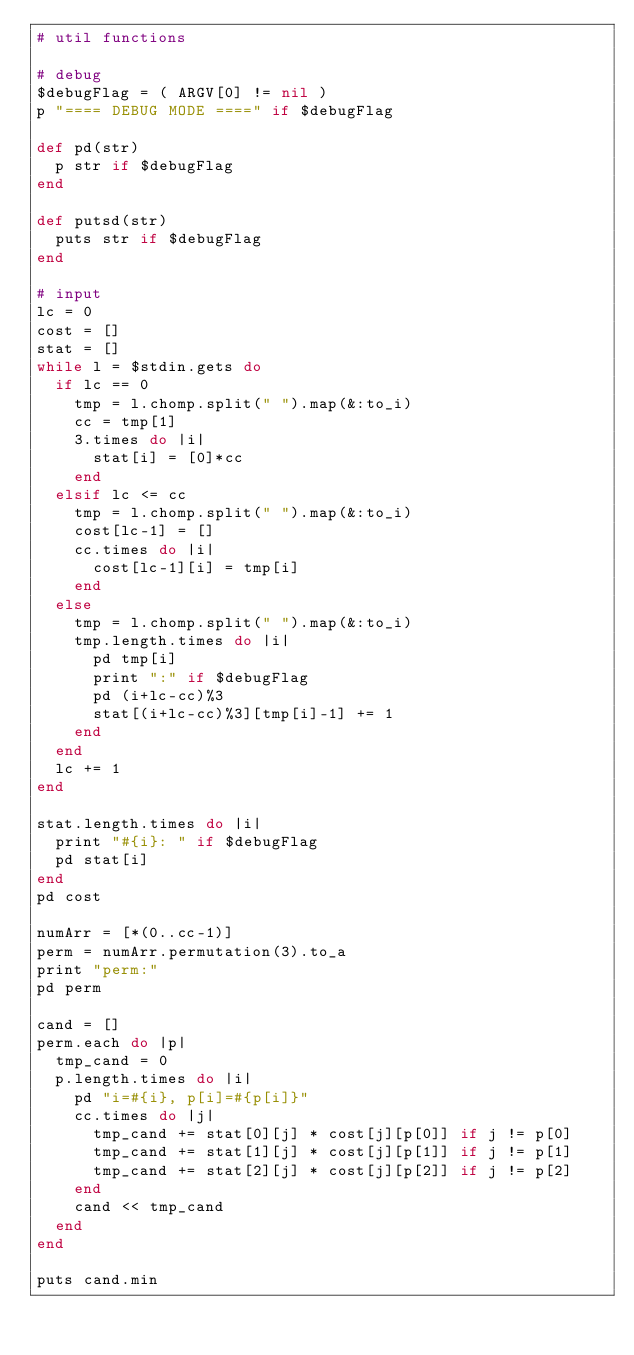<code> <loc_0><loc_0><loc_500><loc_500><_Ruby_># util functions

# debug
$debugFlag = ( ARGV[0] != nil )
p "==== DEBUG MODE ====" if $debugFlag

def pd(str)
  p str if $debugFlag
end

def putsd(str)
  puts str if $debugFlag
end

# input
lc = 0
cost = []
stat = []
while l = $stdin.gets do
  if lc == 0
    tmp = l.chomp.split(" ").map(&:to_i)
    cc = tmp[1]
    3.times do |i|
      stat[i] = [0]*cc
    end
  elsif lc <= cc
    tmp = l.chomp.split(" ").map(&:to_i)
    cost[lc-1] = []
    cc.times do |i|
      cost[lc-1][i] = tmp[i]
    end
  else
    tmp = l.chomp.split(" ").map(&:to_i)
    tmp.length.times do |i|
      pd tmp[i]
      print ":" if $debugFlag
      pd (i+lc-cc)%3
      stat[(i+lc-cc)%3][tmp[i]-1] += 1
    end
  end
  lc += 1
end

stat.length.times do |i|
  print "#{i}: " if $debugFlag
  pd stat[i]
end
pd cost

numArr = [*(0..cc-1)]
perm = numArr.permutation(3).to_a
print "perm:"
pd perm

cand = []
perm.each do |p|
  tmp_cand = 0
  p.length.times do |i|
    pd "i=#{i}, p[i]=#{p[i]}"
    cc.times do |j|
      tmp_cand += stat[0][j] * cost[j][p[0]] if j != p[0]
      tmp_cand += stat[1][j] * cost[j][p[1]] if j != p[1]
      tmp_cand += stat[2][j] * cost[j][p[2]] if j != p[2]
    end
    cand << tmp_cand
  end
end

puts cand.min
</code> 